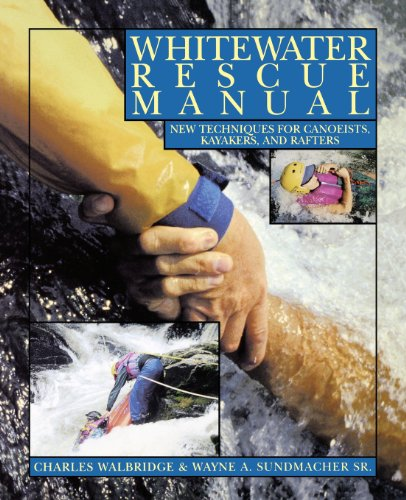Is this book related to Sports & Outdoors? Yes, this book is directly related to the 'Sports & Outdoors' category, offering in-depth insights into safety and rescue operations for water-based activities. 